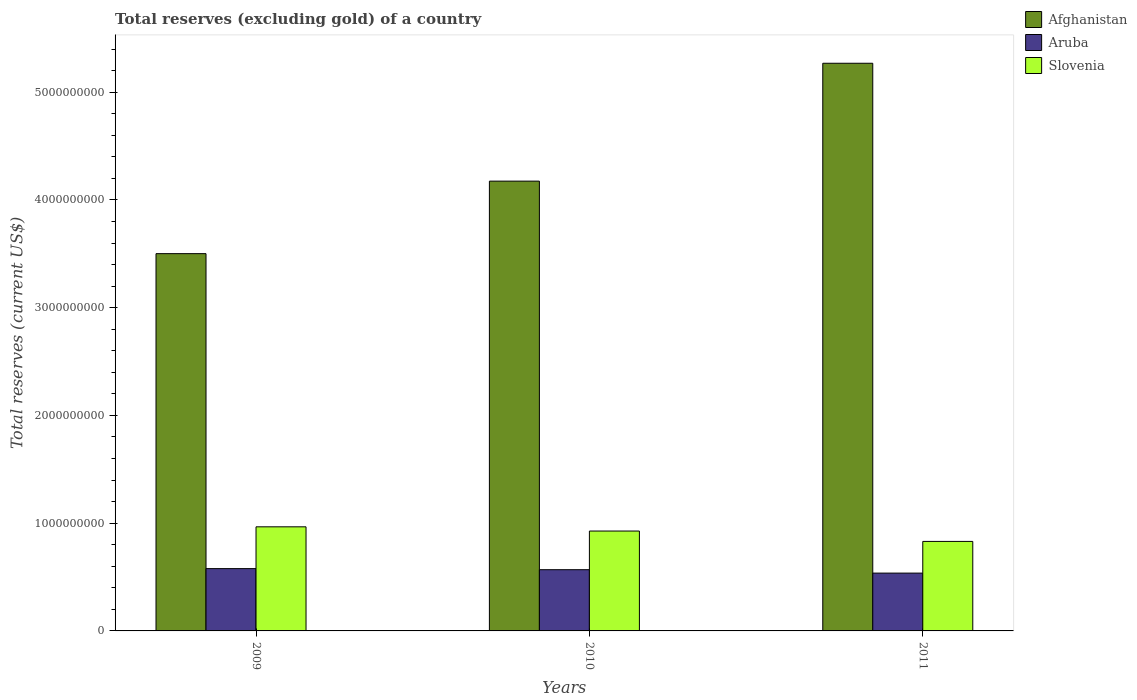How many different coloured bars are there?
Keep it short and to the point. 3. How many bars are there on the 3rd tick from the left?
Your answer should be very brief. 3. In how many cases, is the number of bars for a given year not equal to the number of legend labels?
Offer a very short reply. 0. What is the total reserves (excluding gold) in Slovenia in 2009?
Offer a very short reply. 9.66e+08. Across all years, what is the maximum total reserves (excluding gold) in Afghanistan?
Your answer should be very brief. 5.27e+09. Across all years, what is the minimum total reserves (excluding gold) in Aruba?
Keep it short and to the point. 5.37e+08. In which year was the total reserves (excluding gold) in Aruba minimum?
Provide a short and direct response. 2011. What is the total total reserves (excluding gold) in Slovenia in the graph?
Your response must be concise. 2.72e+09. What is the difference between the total reserves (excluding gold) in Afghanistan in 2009 and that in 2011?
Your answer should be very brief. -1.77e+09. What is the difference between the total reserves (excluding gold) in Aruba in 2011 and the total reserves (excluding gold) in Afghanistan in 2009?
Provide a succinct answer. -2.96e+09. What is the average total reserves (excluding gold) in Slovenia per year?
Give a very brief answer. 9.08e+08. In the year 2009, what is the difference between the total reserves (excluding gold) in Afghanistan and total reserves (excluding gold) in Slovenia?
Make the answer very short. 2.54e+09. What is the ratio of the total reserves (excluding gold) in Aruba in 2010 to that in 2011?
Your answer should be very brief. 1.06. Is the difference between the total reserves (excluding gold) in Afghanistan in 2009 and 2011 greater than the difference between the total reserves (excluding gold) in Slovenia in 2009 and 2011?
Your response must be concise. No. What is the difference between the highest and the second highest total reserves (excluding gold) in Slovenia?
Keep it short and to the point. 3.92e+07. What is the difference between the highest and the lowest total reserves (excluding gold) in Aruba?
Offer a very short reply. 4.15e+07. In how many years, is the total reserves (excluding gold) in Slovenia greater than the average total reserves (excluding gold) in Slovenia taken over all years?
Your response must be concise. 2. What does the 1st bar from the left in 2011 represents?
Provide a succinct answer. Afghanistan. What does the 1st bar from the right in 2011 represents?
Make the answer very short. Slovenia. How many bars are there?
Give a very brief answer. 9. Are all the bars in the graph horizontal?
Give a very brief answer. No. What is the difference between two consecutive major ticks on the Y-axis?
Offer a very short reply. 1.00e+09. Are the values on the major ticks of Y-axis written in scientific E-notation?
Make the answer very short. No. Does the graph contain any zero values?
Offer a terse response. No. Where does the legend appear in the graph?
Provide a short and direct response. Top right. How many legend labels are there?
Make the answer very short. 3. What is the title of the graph?
Give a very brief answer. Total reserves (excluding gold) of a country. What is the label or title of the X-axis?
Your answer should be very brief. Years. What is the label or title of the Y-axis?
Your answer should be very brief. Total reserves (current US$). What is the Total reserves (current US$) of Afghanistan in 2009?
Your answer should be compact. 3.50e+09. What is the Total reserves (current US$) of Aruba in 2009?
Keep it short and to the point. 5.78e+08. What is the Total reserves (current US$) of Slovenia in 2009?
Provide a succinct answer. 9.66e+08. What is the Total reserves (current US$) of Afghanistan in 2010?
Provide a succinct answer. 4.17e+09. What is the Total reserves (current US$) of Aruba in 2010?
Offer a very short reply. 5.68e+08. What is the Total reserves (current US$) in Slovenia in 2010?
Your answer should be very brief. 9.27e+08. What is the Total reserves (current US$) in Afghanistan in 2011?
Offer a terse response. 5.27e+09. What is the Total reserves (current US$) in Aruba in 2011?
Provide a succinct answer. 5.37e+08. What is the Total reserves (current US$) in Slovenia in 2011?
Your answer should be very brief. 8.31e+08. Across all years, what is the maximum Total reserves (current US$) in Afghanistan?
Keep it short and to the point. 5.27e+09. Across all years, what is the maximum Total reserves (current US$) of Aruba?
Provide a succinct answer. 5.78e+08. Across all years, what is the maximum Total reserves (current US$) in Slovenia?
Make the answer very short. 9.66e+08. Across all years, what is the minimum Total reserves (current US$) of Afghanistan?
Make the answer very short. 3.50e+09. Across all years, what is the minimum Total reserves (current US$) in Aruba?
Offer a terse response. 5.37e+08. Across all years, what is the minimum Total reserves (current US$) of Slovenia?
Provide a succinct answer. 8.31e+08. What is the total Total reserves (current US$) in Afghanistan in the graph?
Make the answer very short. 1.29e+1. What is the total Total reserves (current US$) of Aruba in the graph?
Keep it short and to the point. 1.68e+09. What is the total Total reserves (current US$) in Slovenia in the graph?
Provide a short and direct response. 2.72e+09. What is the difference between the Total reserves (current US$) in Afghanistan in 2009 and that in 2010?
Provide a succinct answer. -6.73e+08. What is the difference between the Total reserves (current US$) in Aruba in 2009 and that in 2010?
Offer a terse response. 1.01e+07. What is the difference between the Total reserves (current US$) of Slovenia in 2009 and that in 2010?
Ensure brevity in your answer.  3.92e+07. What is the difference between the Total reserves (current US$) of Afghanistan in 2009 and that in 2011?
Your answer should be compact. -1.77e+09. What is the difference between the Total reserves (current US$) in Aruba in 2009 and that in 2011?
Your response must be concise. 4.15e+07. What is the difference between the Total reserves (current US$) in Slovenia in 2009 and that in 2011?
Offer a very short reply. 1.35e+08. What is the difference between the Total reserves (current US$) of Afghanistan in 2010 and that in 2011?
Offer a terse response. -1.09e+09. What is the difference between the Total reserves (current US$) in Aruba in 2010 and that in 2011?
Your response must be concise. 3.15e+07. What is the difference between the Total reserves (current US$) of Slovenia in 2010 and that in 2011?
Make the answer very short. 9.62e+07. What is the difference between the Total reserves (current US$) of Afghanistan in 2009 and the Total reserves (current US$) of Aruba in 2010?
Make the answer very short. 2.93e+09. What is the difference between the Total reserves (current US$) in Afghanistan in 2009 and the Total reserves (current US$) in Slovenia in 2010?
Ensure brevity in your answer.  2.57e+09. What is the difference between the Total reserves (current US$) of Aruba in 2009 and the Total reserves (current US$) of Slovenia in 2010?
Give a very brief answer. -3.49e+08. What is the difference between the Total reserves (current US$) of Afghanistan in 2009 and the Total reserves (current US$) of Aruba in 2011?
Offer a very short reply. 2.96e+09. What is the difference between the Total reserves (current US$) of Afghanistan in 2009 and the Total reserves (current US$) of Slovenia in 2011?
Offer a terse response. 2.67e+09. What is the difference between the Total reserves (current US$) in Aruba in 2009 and the Total reserves (current US$) in Slovenia in 2011?
Offer a very short reply. -2.53e+08. What is the difference between the Total reserves (current US$) of Afghanistan in 2010 and the Total reserves (current US$) of Aruba in 2011?
Provide a short and direct response. 3.64e+09. What is the difference between the Total reserves (current US$) in Afghanistan in 2010 and the Total reserves (current US$) in Slovenia in 2011?
Provide a short and direct response. 3.34e+09. What is the difference between the Total reserves (current US$) in Aruba in 2010 and the Total reserves (current US$) in Slovenia in 2011?
Provide a succinct answer. -2.63e+08. What is the average Total reserves (current US$) of Afghanistan per year?
Provide a short and direct response. 4.31e+09. What is the average Total reserves (current US$) of Aruba per year?
Provide a succinct answer. 5.61e+08. What is the average Total reserves (current US$) of Slovenia per year?
Make the answer very short. 9.08e+08. In the year 2009, what is the difference between the Total reserves (current US$) of Afghanistan and Total reserves (current US$) of Aruba?
Keep it short and to the point. 2.92e+09. In the year 2009, what is the difference between the Total reserves (current US$) in Afghanistan and Total reserves (current US$) in Slovenia?
Offer a terse response. 2.54e+09. In the year 2009, what is the difference between the Total reserves (current US$) of Aruba and Total reserves (current US$) of Slovenia?
Offer a very short reply. -3.88e+08. In the year 2010, what is the difference between the Total reserves (current US$) in Afghanistan and Total reserves (current US$) in Aruba?
Give a very brief answer. 3.61e+09. In the year 2010, what is the difference between the Total reserves (current US$) of Afghanistan and Total reserves (current US$) of Slovenia?
Offer a terse response. 3.25e+09. In the year 2010, what is the difference between the Total reserves (current US$) in Aruba and Total reserves (current US$) in Slovenia?
Provide a short and direct response. -3.59e+08. In the year 2011, what is the difference between the Total reserves (current US$) in Afghanistan and Total reserves (current US$) in Aruba?
Your response must be concise. 4.73e+09. In the year 2011, what is the difference between the Total reserves (current US$) of Afghanistan and Total reserves (current US$) of Slovenia?
Give a very brief answer. 4.44e+09. In the year 2011, what is the difference between the Total reserves (current US$) of Aruba and Total reserves (current US$) of Slovenia?
Offer a very short reply. -2.94e+08. What is the ratio of the Total reserves (current US$) in Afghanistan in 2009 to that in 2010?
Ensure brevity in your answer.  0.84. What is the ratio of the Total reserves (current US$) of Aruba in 2009 to that in 2010?
Offer a terse response. 1.02. What is the ratio of the Total reserves (current US$) of Slovenia in 2009 to that in 2010?
Offer a terse response. 1.04. What is the ratio of the Total reserves (current US$) of Afghanistan in 2009 to that in 2011?
Provide a succinct answer. 0.66. What is the ratio of the Total reserves (current US$) in Aruba in 2009 to that in 2011?
Make the answer very short. 1.08. What is the ratio of the Total reserves (current US$) of Slovenia in 2009 to that in 2011?
Ensure brevity in your answer.  1.16. What is the ratio of the Total reserves (current US$) in Afghanistan in 2010 to that in 2011?
Provide a succinct answer. 0.79. What is the ratio of the Total reserves (current US$) in Aruba in 2010 to that in 2011?
Provide a succinct answer. 1.06. What is the ratio of the Total reserves (current US$) of Slovenia in 2010 to that in 2011?
Provide a short and direct response. 1.12. What is the difference between the highest and the second highest Total reserves (current US$) of Afghanistan?
Keep it short and to the point. 1.09e+09. What is the difference between the highest and the second highest Total reserves (current US$) in Aruba?
Ensure brevity in your answer.  1.01e+07. What is the difference between the highest and the second highest Total reserves (current US$) of Slovenia?
Offer a very short reply. 3.92e+07. What is the difference between the highest and the lowest Total reserves (current US$) of Afghanistan?
Provide a short and direct response. 1.77e+09. What is the difference between the highest and the lowest Total reserves (current US$) in Aruba?
Your answer should be very brief. 4.15e+07. What is the difference between the highest and the lowest Total reserves (current US$) of Slovenia?
Offer a terse response. 1.35e+08. 